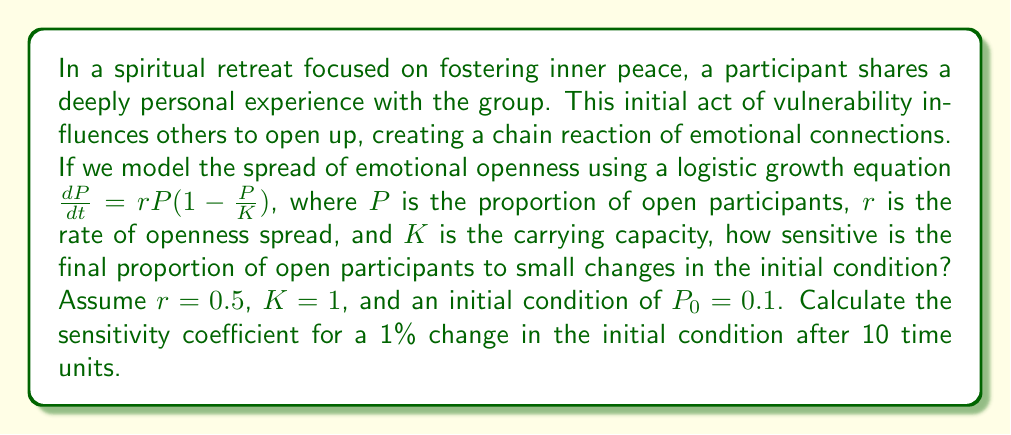What is the answer to this math problem? To analyze the sensitivity of the system to small changes in the initial condition, we'll follow these steps:

1) First, we need to solve the logistic growth equation:
   $$\frac{dP}{dt} = rP(1-\frac{P}{K})$$

   The solution to this equation is:
   $$P(t) = \frac{KP_0e^{rt}}{K + P_0(e^{rt} - 1)}$$

2) Let's substitute our values: $r=0.5$, $K=1$, $P_0=0.1$, and $t=10$:
   $$P(10) = \frac{1 \cdot 0.1e^{0.5 \cdot 10}}{1 + 0.1(e^{0.5 \cdot 10} - 1)} \approx 0.9933$$

3) Now, let's calculate $P(10)$ with a 1% increase in the initial condition ($P_0 = 0.101$):
   $$P_{new}(10) = \frac{1 \cdot 0.101e^{0.5 \cdot 10}}{1 + 0.101(e^{0.5 \cdot 10} - 1)} \approx 0.9934$$

4) The sensitivity coefficient is defined as:
   $$S = \frac{\text{Fractional change in output}}{\text{Fractional change in input}}$$

5) Calculate the fractional changes:
   Fractional change in input = $(0.101 - 0.1) / 0.1 = 0.01$ (1%)
   Fractional change in output = $(0.9934 - 0.9933) / 0.9933 \approx 0.0001$ (0.01%)

6) Calculate the sensitivity coefficient:
   $$S = \frac{0.0001}{0.01} = 0.01$$
Answer: 0.01 